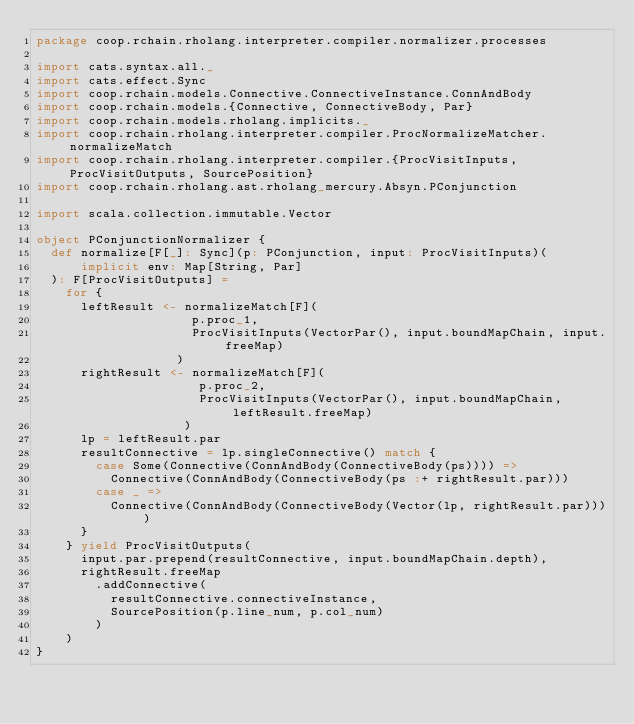Convert code to text. <code><loc_0><loc_0><loc_500><loc_500><_Scala_>package coop.rchain.rholang.interpreter.compiler.normalizer.processes

import cats.syntax.all._
import cats.effect.Sync
import coop.rchain.models.Connective.ConnectiveInstance.ConnAndBody
import coop.rchain.models.{Connective, ConnectiveBody, Par}
import coop.rchain.models.rholang.implicits._
import coop.rchain.rholang.interpreter.compiler.ProcNormalizeMatcher.normalizeMatch
import coop.rchain.rholang.interpreter.compiler.{ProcVisitInputs, ProcVisitOutputs, SourcePosition}
import coop.rchain.rholang.ast.rholang_mercury.Absyn.PConjunction

import scala.collection.immutable.Vector

object PConjunctionNormalizer {
  def normalize[F[_]: Sync](p: PConjunction, input: ProcVisitInputs)(
      implicit env: Map[String, Par]
  ): F[ProcVisitOutputs] =
    for {
      leftResult <- normalizeMatch[F](
                     p.proc_1,
                     ProcVisitInputs(VectorPar(), input.boundMapChain, input.freeMap)
                   )
      rightResult <- normalizeMatch[F](
                      p.proc_2,
                      ProcVisitInputs(VectorPar(), input.boundMapChain, leftResult.freeMap)
                    )
      lp = leftResult.par
      resultConnective = lp.singleConnective() match {
        case Some(Connective(ConnAndBody(ConnectiveBody(ps)))) =>
          Connective(ConnAndBody(ConnectiveBody(ps :+ rightResult.par)))
        case _ =>
          Connective(ConnAndBody(ConnectiveBody(Vector(lp, rightResult.par))))
      }
    } yield ProcVisitOutputs(
      input.par.prepend(resultConnective, input.boundMapChain.depth),
      rightResult.freeMap
        .addConnective(
          resultConnective.connectiveInstance,
          SourcePosition(p.line_num, p.col_num)
        )
    )
}
</code> 